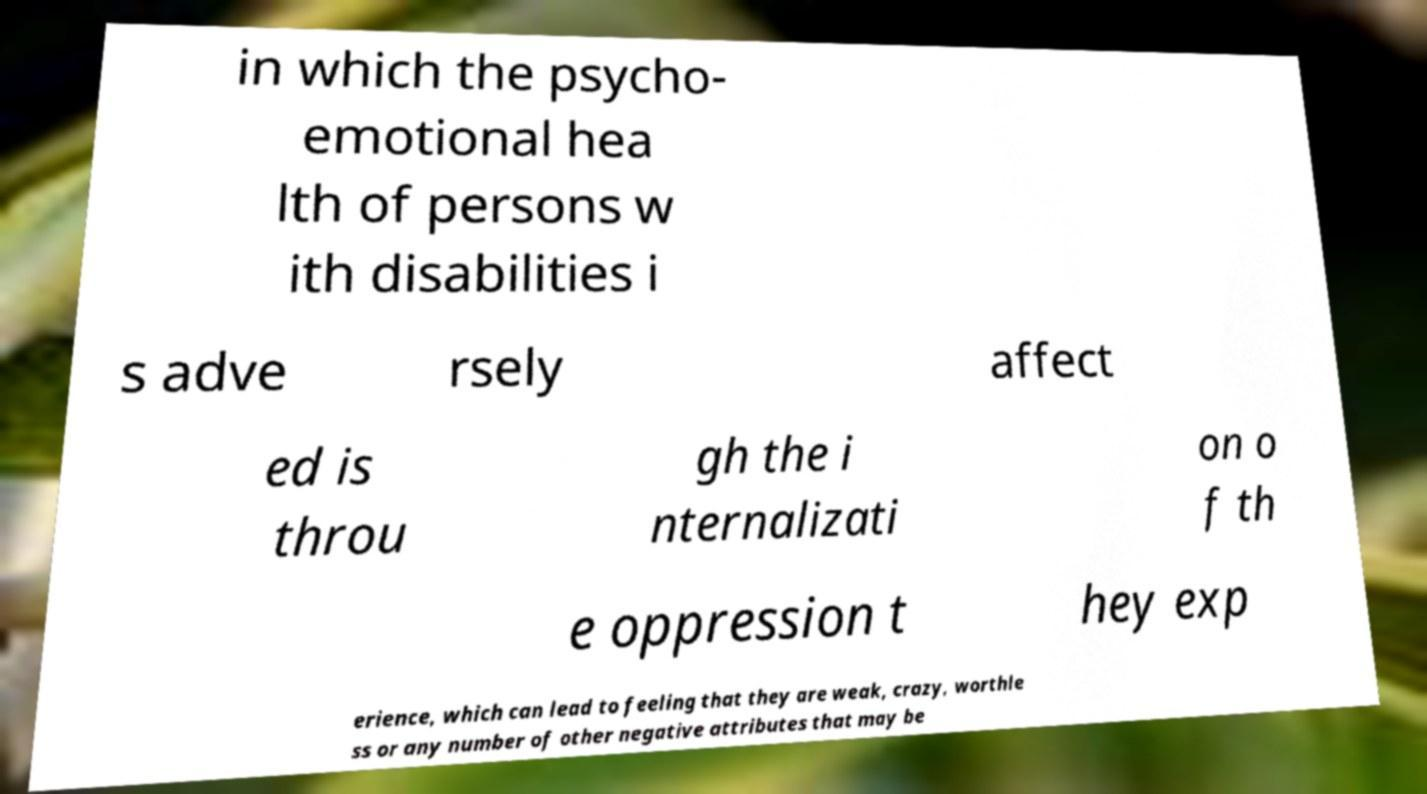Can you read and provide the text displayed in the image?This photo seems to have some interesting text. Can you extract and type it out for me? in which the psycho- emotional hea lth of persons w ith disabilities i s adve rsely affect ed is throu gh the i nternalizati on o f th e oppression t hey exp erience, which can lead to feeling that they are weak, crazy, worthle ss or any number of other negative attributes that may be 